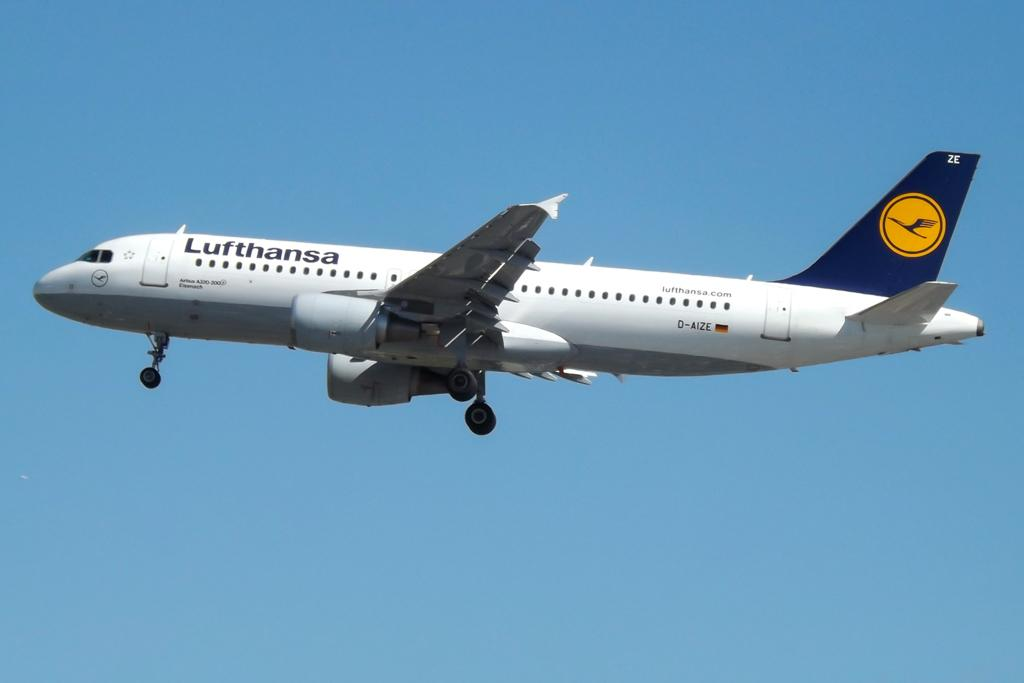<image>
Summarize the visual content of the image. a Lufthansa plane in the air in daytime 